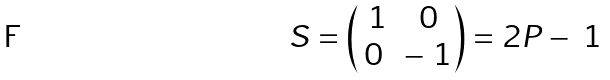<formula> <loc_0><loc_0><loc_500><loc_500>S = \begin{pmatrix} \ 1 & 0 \\ 0 & - \ 1 \end{pmatrix} = 2 P - \ 1</formula> 